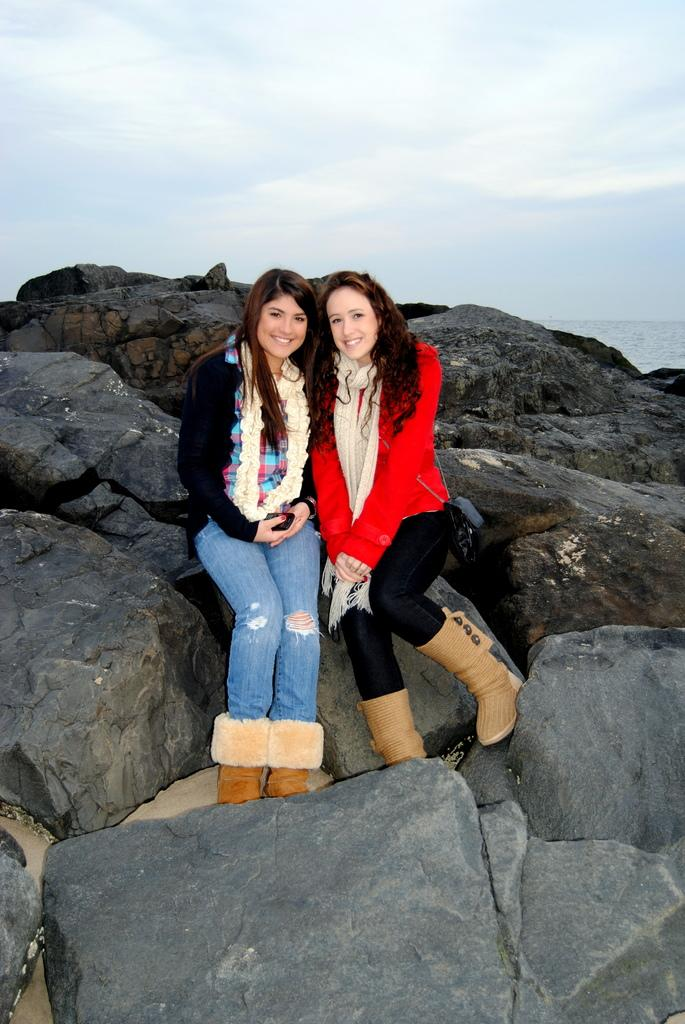How many people are in the image? There are two women in the image. What are the women sitting on? The women are sitting on rocks. What type of clothing are the women wearing? The women are wearing jackets, scarves, and boots. What is visible at the top of the image? The sky is visible at the top of the image. Can you see any rabbits hopping around in the image? There are no rabbits present in the image. What type of grass is growing on the rocks where the women are sitting? There is no grass visible in the image; the women are sitting on rocks. 